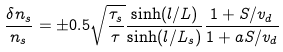Convert formula to latex. <formula><loc_0><loc_0><loc_500><loc_500>\frac { \delta n _ { s } } { n _ { s } } = \pm 0 . 5 \sqrt { \frac { \tau _ { s } } { \tau } } \frac { \sinh ( l / L ) } { \sinh ( l / L _ { s } ) } \frac { 1 + S / v _ { d } } { 1 + a S / v _ { d } }</formula> 